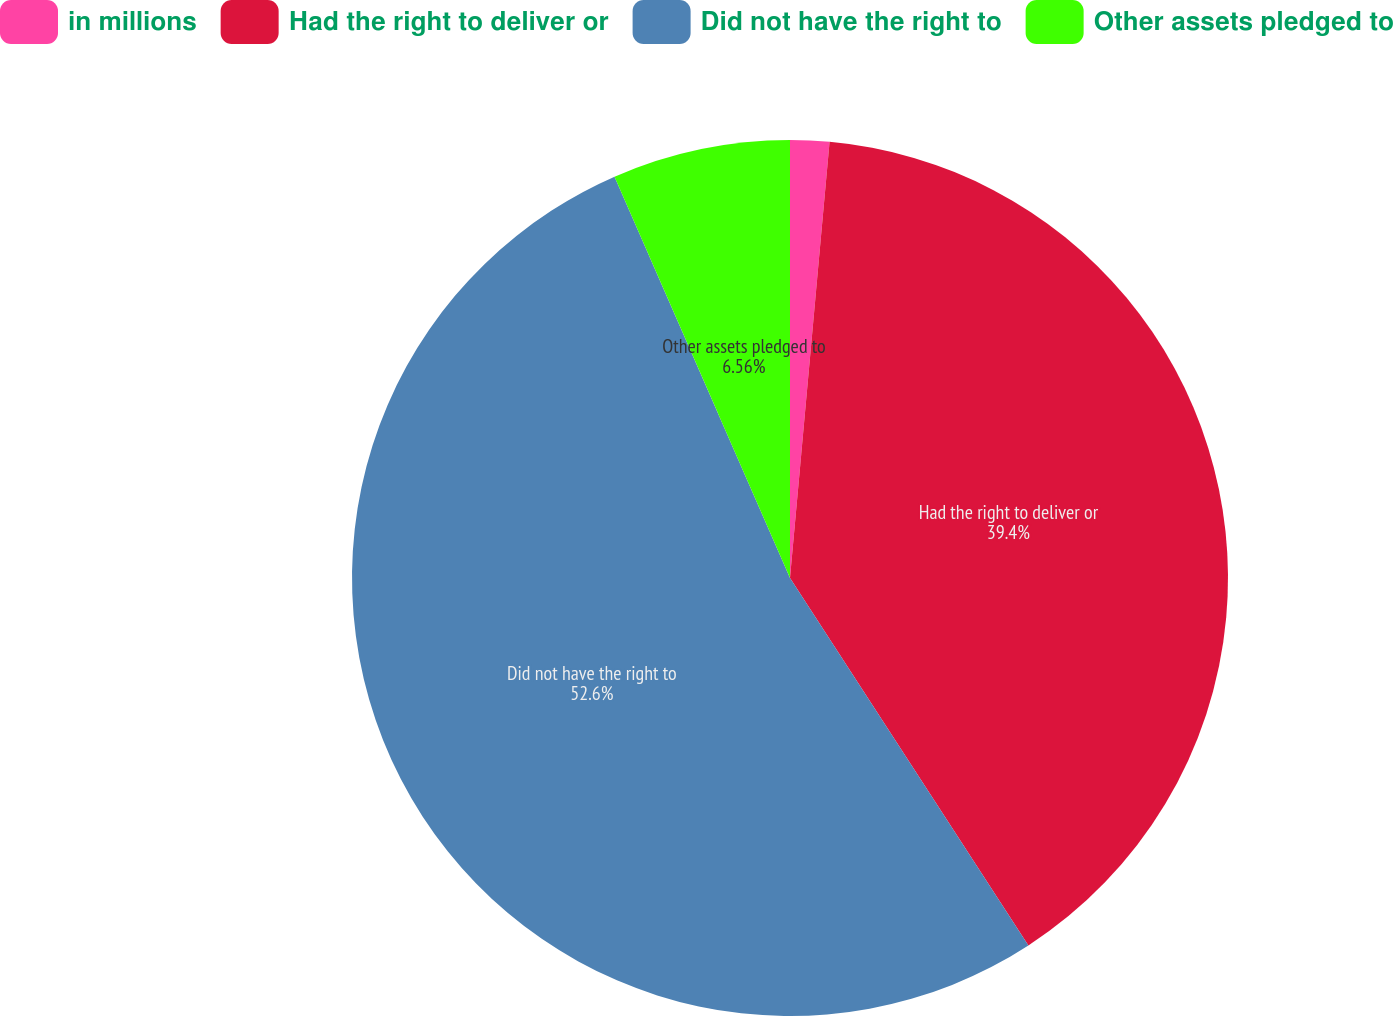Convert chart. <chart><loc_0><loc_0><loc_500><loc_500><pie_chart><fcel>in millions<fcel>Had the right to deliver or<fcel>Did not have the right to<fcel>Other assets pledged to<nl><fcel>1.44%<fcel>39.4%<fcel>52.6%<fcel>6.56%<nl></chart> 